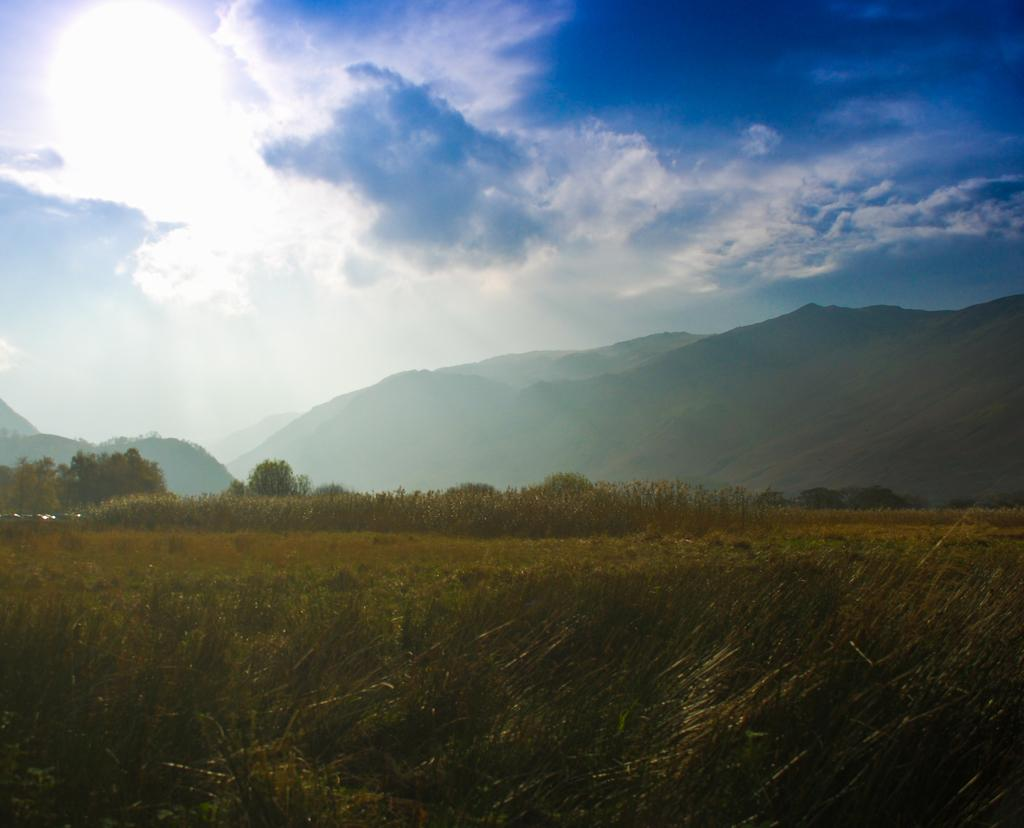What type of vegetation is present at the bottom of the image? There are plants and grass at the bottom of the image. What type of natural features can be seen in the background of the image? There are mountains and trees in the background of the image. What is visible at the top of the image? The sky is visible at the top of the image. Who is the creator of the mountains in the image? The mountains in the image are a natural formation and do not have a specific creator. How many apples are hanging from the trees in the image? There are no apples visible in the image; only trees and mountains are present. 